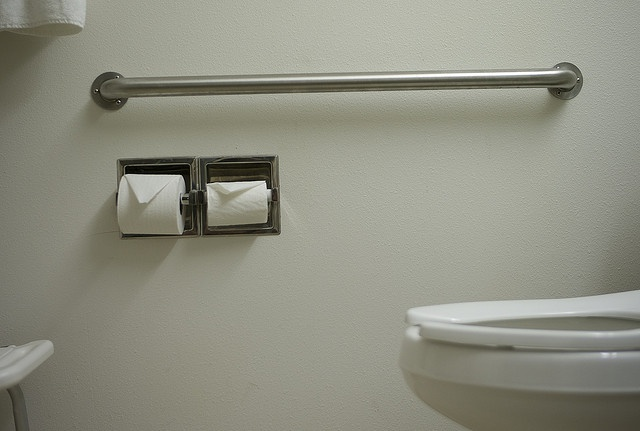Describe the objects in this image and their specific colors. I can see a toilet in gray, darkgray, and lightgray tones in this image. 